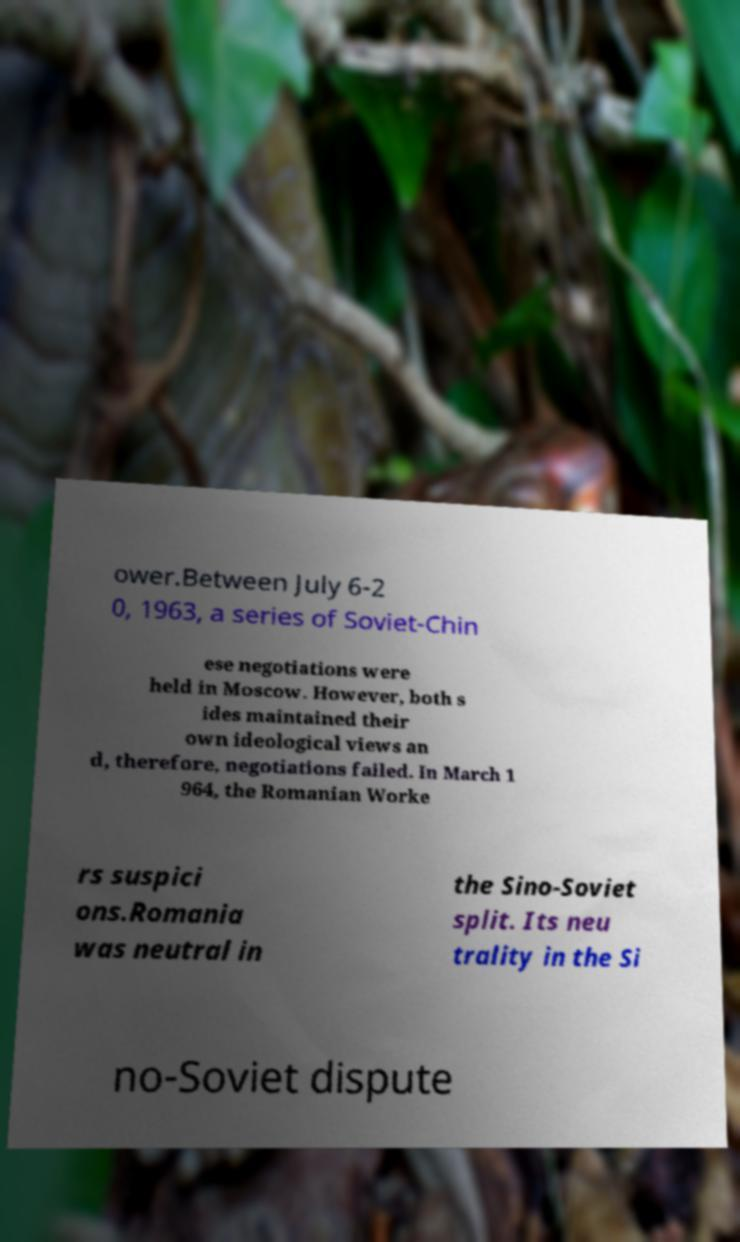Please read and relay the text visible in this image. What does it say? ower.Between July 6-2 0, 1963, a series of Soviet-Chin ese negotiations were held in Moscow. However, both s ides maintained their own ideological views an d, therefore, negotiations failed. In March 1 964, the Romanian Worke rs suspici ons.Romania was neutral in the Sino-Soviet split. Its neu trality in the Si no-Soviet dispute 